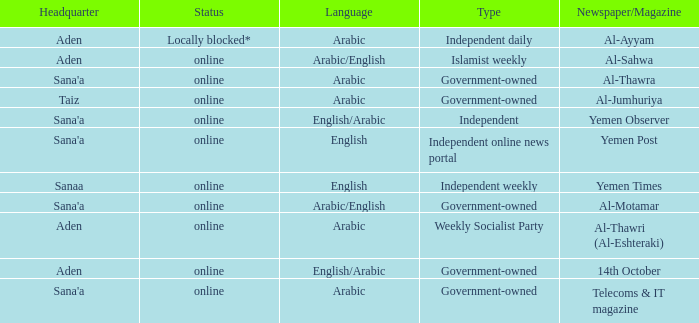Could you parse the entire table as a dict? {'header': ['Headquarter', 'Status', 'Language', 'Type', 'Newspaper/Magazine'], 'rows': [['Aden', 'Locally blocked*', 'Arabic', 'Independent daily', 'Al-Ayyam'], ['Aden', 'online', 'Arabic/English', 'Islamist weekly', 'Al-Sahwa'], ["Sana'a", 'online', 'Arabic', 'Government-owned', 'Al-Thawra'], ['Taiz', 'online', 'Arabic', 'Government-owned', 'Al-Jumhuriya'], ["Sana'a", 'online', 'English/Arabic', 'Independent', 'Yemen Observer'], ["Sana'a", 'online', 'English', 'Independent online news portal', 'Yemen Post'], ['Sanaa', 'online', 'English', 'Independent weekly', 'Yemen Times'], ["Sana'a", 'online', 'Arabic/English', 'Government-owned', 'Al-Motamar'], ['Aden', 'online', 'Arabic', 'Weekly Socialist Party', 'Al-Thawri (Al-Eshteraki)'], ['Aden', 'online', 'English/Arabic', 'Government-owned', '14th October'], ["Sana'a", 'online', 'Arabic', 'Government-owned', 'Telecoms & IT magazine']]} In the case of al-thawra newspaper/magazine, what is the current status? Online. 